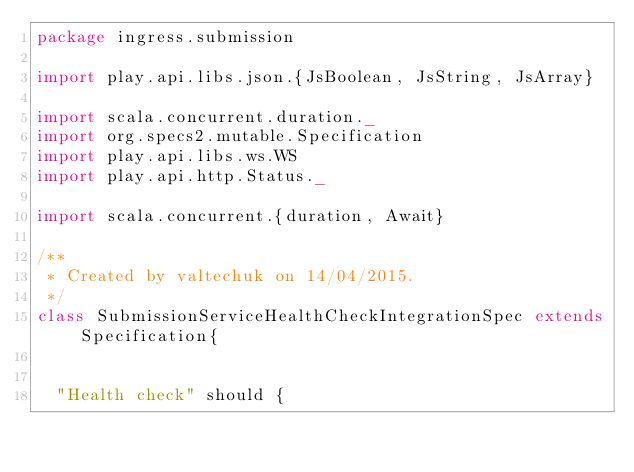Convert code to text. <code><loc_0><loc_0><loc_500><loc_500><_Scala_>package ingress.submission

import play.api.libs.json.{JsBoolean, JsString, JsArray}

import scala.concurrent.duration._
import org.specs2.mutable.Specification
import play.api.libs.ws.WS
import play.api.http.Status._

import scala.concurrent.{duration, Await}

/**
 * Created by valtechuk on 14/04/2015.
 */
class SubmissionServiceHealthCheckIntegrationSpec extends Specification{


  "Health check" should {</code> 